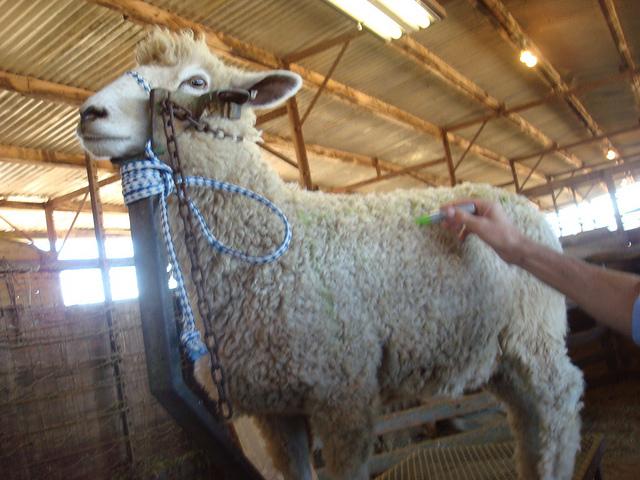What manufacturing processes can this animal be used for?
Short answer required. Wool. What item is made from this animal's fur?
Give a very brief answer. Wool. What is the person touching?
Quick response, please. Sheep. 